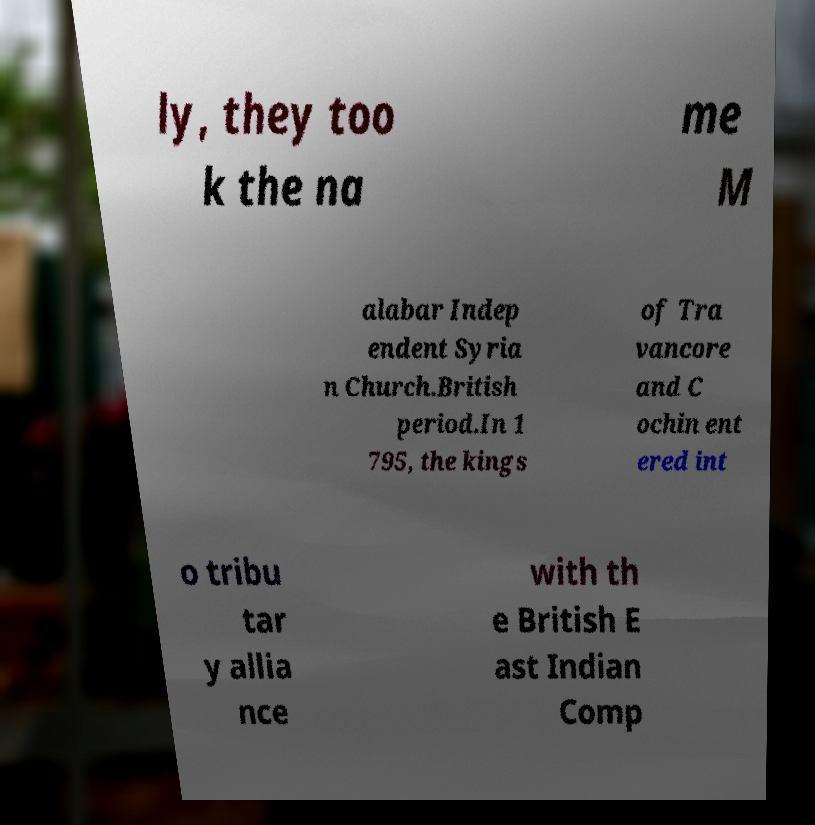There's text embedded in this image that I need extracted. Can you transcribe it verbatim? ly, they too k the na me M alabar Indep endent Syria n Church.British period.In 1 795, the kings of Tra vancore and C ochin ent ered int o tribu tar y allia nce with th e British E ast Indian Comp 